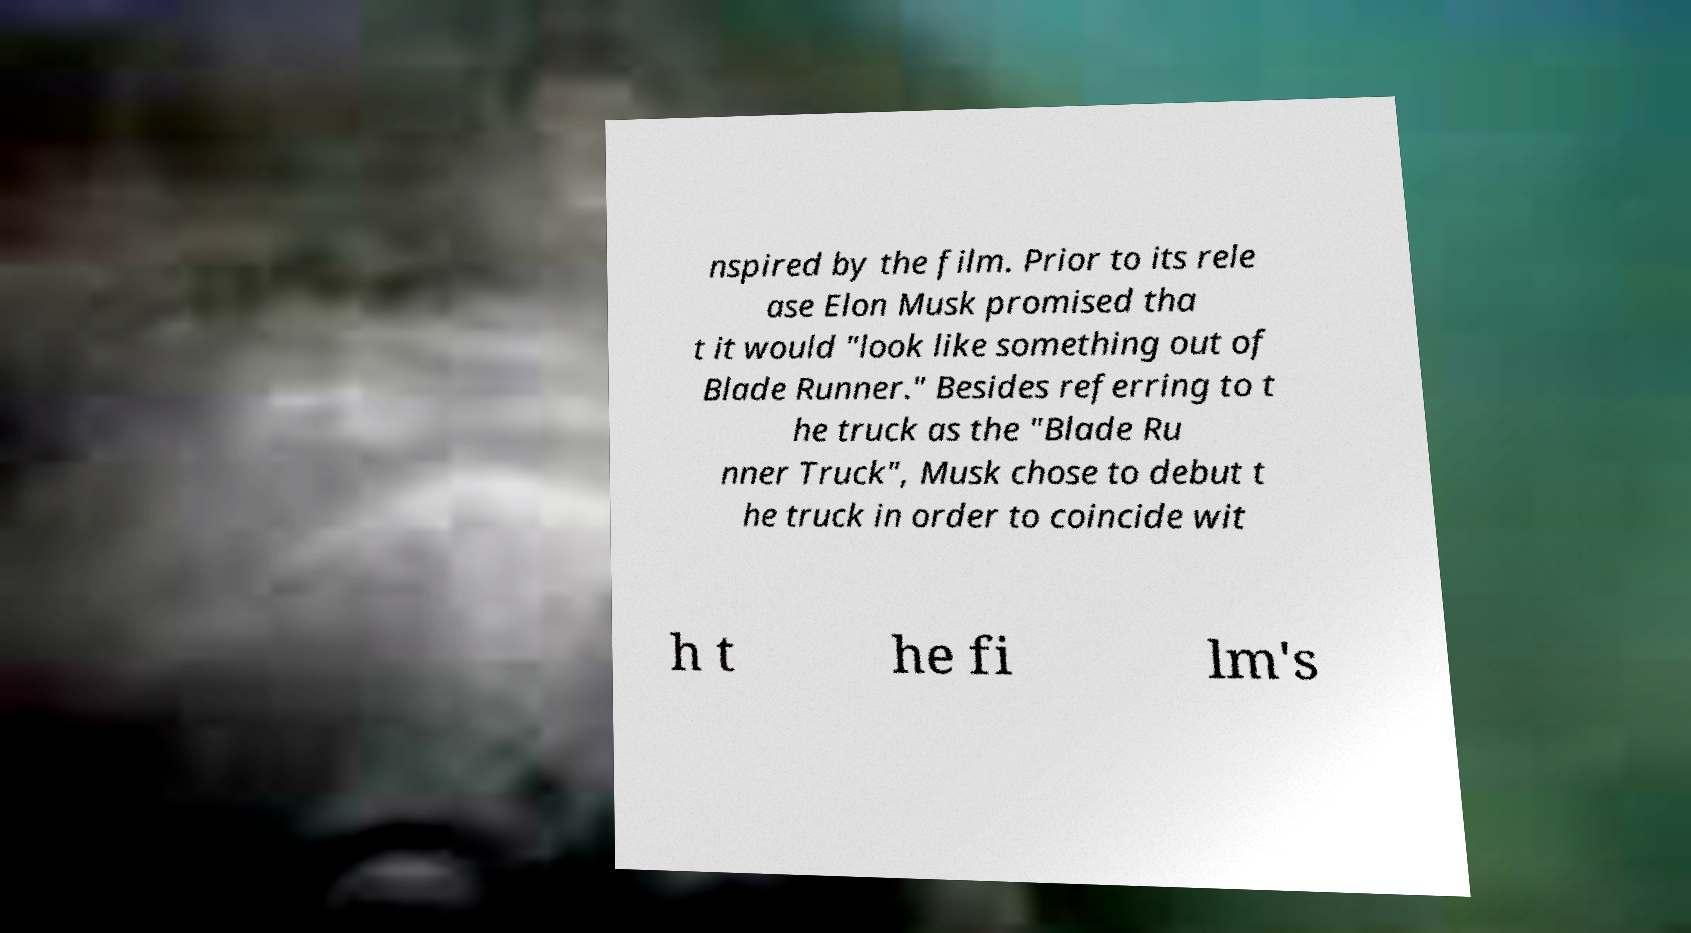Could you extract and type out the text from this image? nspired by the film. Prior to its rele ase Elon Musk promised tha t it would "look like something out of Blade Runner." Besides referring to t he truck as the "Blade Ru nner Truck", Musk chose to debut t he truck in order to coincide wit h t he fi lm's 